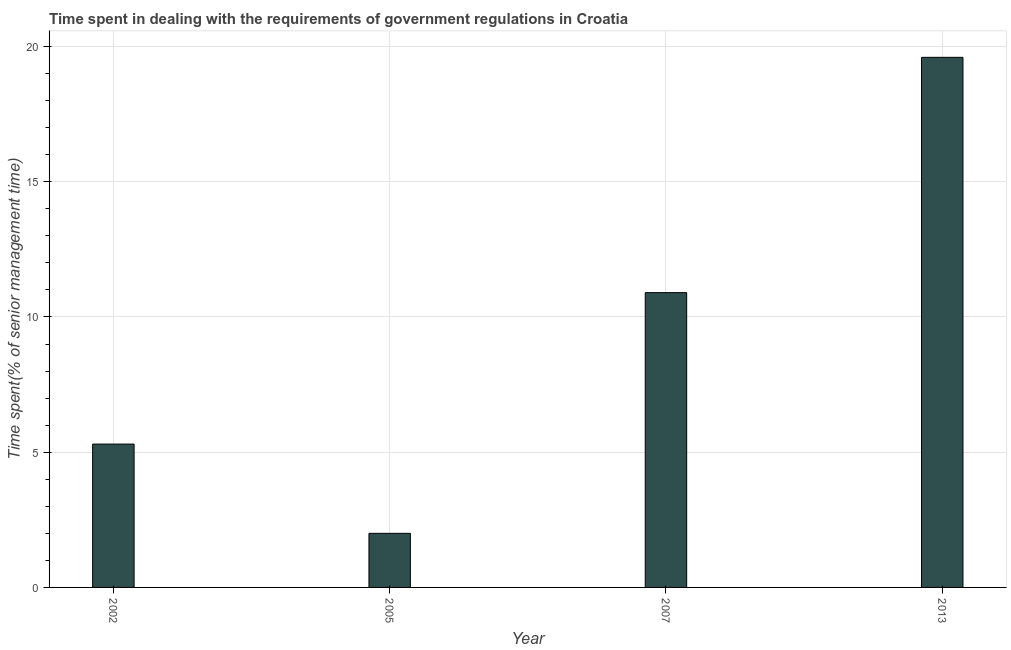Does the graph contain grids?
Provide a succinct answer. Yes. What is the title of the graph?
Your response must be concise. Time spent in dealing with the requirements of government regulations in Croatia. What is the label or title of the Y-axis?
Make the answer very short. Time spent(% of senior management time). What is the time spent in dealing with government regulations in 2013?
Ensure brevity in your answer.  19.6. Across all years, what is the maximum time spent in dealing with government regulations?
Provide a short and direct response. 19.6. Across all years, what is the minimum time spent in dealing with government regulations?
Your answer should be very brief. 2. In which year was the time spent in dealing with government regulations minimum?
Ensure brevity in your answer.  2005. What is the sum of the time spent in dealing with government regulations?
Make the answer very short. 37.8. What is the difference between the time spent in dealing with government regulations in 2002 and 2005?
Your answer should be compact. 3.3. What is the average time spent in dealing with government regulations per year?
Make the answer very short. 9.45. What is the median time spent in dealing with government regulations?
Your answer should be very brief. 8.1. Do a majority of the years between 2007 and 2005 (inclusive) have time spent in dealing with government regulations greater than 4 %?
Provide a short and direct response. No. What is the ratio of the time spent in dealing with government regulations in 2002 to that in 2013?
Provide a succinct answer. 0.27. Is the time spent in dealing with government regulations in 2002 less than that in 2007?
Ensure brevity in your answer.  Yes. What is the difference between the highest and the second highest time spent in dealing with government regulations?
Keep it short and to the point. 8.7. Is the sum of the time spent in dealing with government regulations in 2002 and 2005 greater than the maximum time spent in dealing with government regulations across all years?
Offer a very short reply. No. In how many years, is the time spent in dealing with government regulations greater than the average time spent in dealing with government regulations taken over all years?
Provide a short and direct response. 2. How many years are there in the graph?
Provide a succinct answer. 4. Are the values on the major ticks of Y-axis written in scientific E-notation?
Provide a succinct answer. No. What is the Time spent(% of senior management time) in 2005?
Offer a very short reply. 2. What is the Time spent(% of senior management time) in 2013?
Make the answer very short. 19.6. What is the difference between the Time spent(% of senior management time) in 2002 and 2005?
Provide a short and direct response. 3.3. What is the difference between the Time spent(% of senior management time) in 2002 and 2013?
Provide a succinct answer. -14.3. What is the difference between the Time spent(% of senior management time) in 2005 and 2013?
Give a very brief answer. -17.6. What is the ratio of the Time spent(% of senior management time) in 2002 to that in 2005?
Make the answer very short. 2.65. What is the ratio of the Time spent(% of senior management time) in 2002 to that in 2007?
Offer a very short reply. 0.49. What is the ratio of the Time spent(% of senior management time) in 2002 to that in 2013?
Make the answer very short. 0.27. What is the ratio of the Time spent(% of senior management time) in 2005 to that in 2007?
Offer a terse response. 0.18. What is the ratio of the Time spent(% of senior management time) in 2005 to that in 2013?
Provide a succinct answer. 0.1. What is the ratio of the Time spent(% of senior management time) in 2007 to that in 2013?
Your response must be concise. 0.56. 